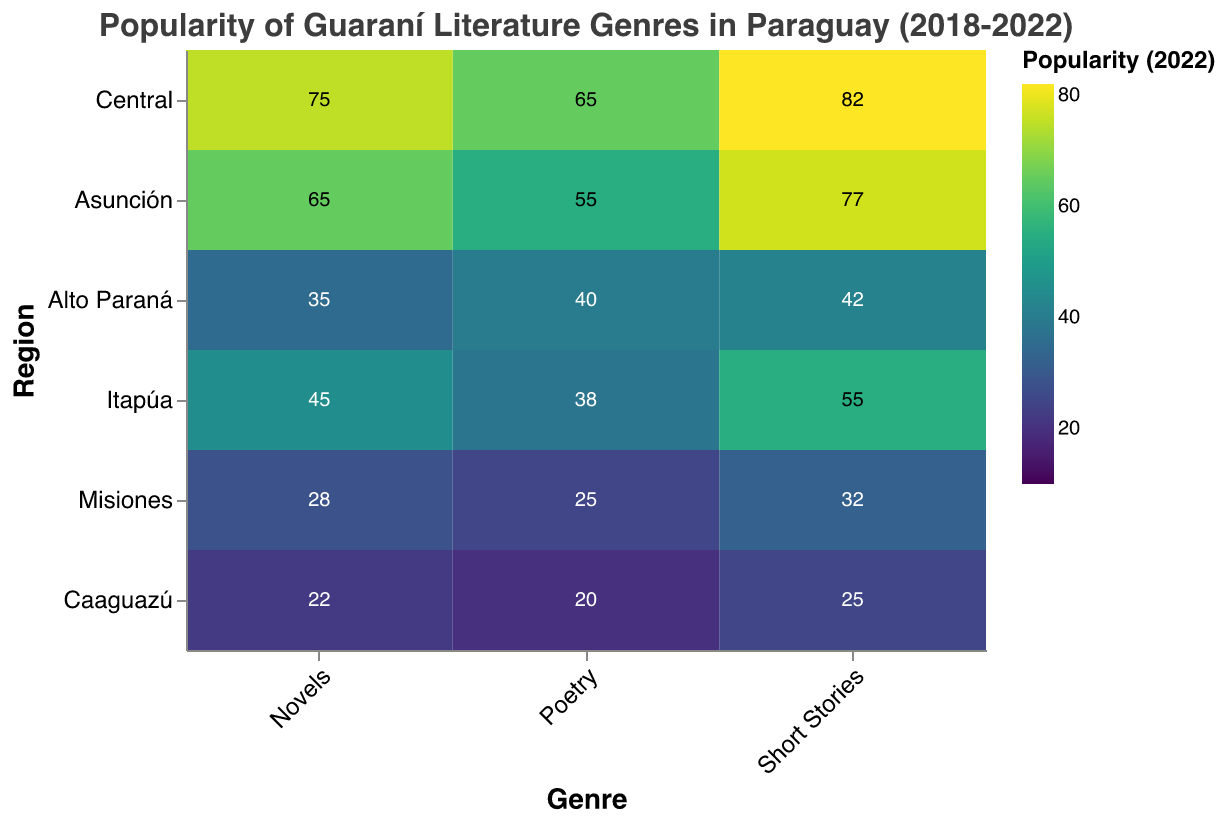How has the popularity of Poetry in Central changed from 2018 to 2022? Observe the color and value of the cell corresponding to Central and Poetry for each year from 2018 (50) to 2022 (65). The color intensity increases, indicating growth.
Answer: Increased from 50 to 65 Which region had the least popularity for Novels in 2022? Compare the colors and values of the cells corresponding to Novels in each region for 2022. The lightest color is in Caaguazú with a value of 22.
Answer: Caaguazú Compare the popularity of Novels in Alto Paraná and Itapúa in 2022. Which region saw a higher popularity? Look at the values for Novels in Alto Paraná (35) and Itapúa (45) in 2022. Itapúa has a higher value.
Answer: Itapúa Which genre in Misiones experienced the highest increase in popularity from 2020 to 2022? Calculate the difference between 2022 and 2020 values for each genre in Misiones: Poetry (25-20=5), Short Stories (32-28=4), Novels (28-22=6). Novels show the highest increase.
Answer: Novels How does the popularity of Novels in Central in 2019 compare to Poetry in Itapúa in 2022? Compare the values: Novels in Central in 2019 (62) and Poetry in Itapúa in 2022 (38). Novels in Central in 2019 is higher.
Answer: Novels in Central in 2019 is higher Which region had the highest popularity for Short Stories in 2022? Identify the region with the highest value for Short Stories in 2022. Central has the highest value (82).
Answer: Central What is the overall trend of Poetry in Alto Paraná from 2018 to 2022? Observe the values for Poetry in Alto Paraná from 2018 (20) to 2022 (40). The values steadily increase, indicating a positive trend.
Answer: Increasing trend Which region shows the most balanced (similar popularity levels) interest in all three genres in 2022? Compare the values of all genres within each region for 2022. Asunción has Poetry (55), Short Stories (77), Novels (65) which are relatively similar compared to others.
Answer: Asunción 